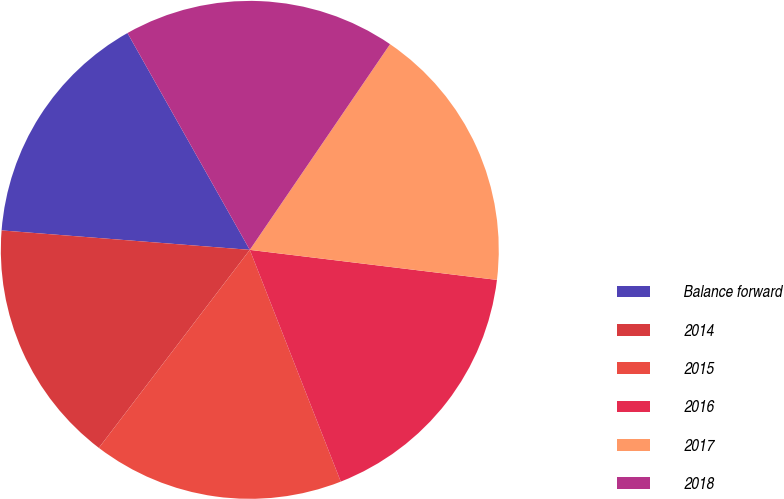<chart> <loc_0><loc_0><loc_500><loc_500><pie_chart><fcel>Balance forward<fcel>2014<fcel>2015<fcel>2016<fcel>2017<fcel>2018<nl><fcel>15.58%<fcel>15.88%<fcel>16.32%<fcel>17.12%<fcel>17.4%<fcel>17.7%<nl></chart> 